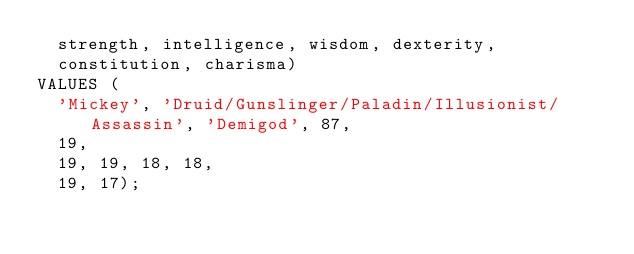<code> <loc_0><loc_0><loc_500><loc_500><_SQL_>  strength, intelligence, wisdom, dexterity,
  constitution, charisma)
VALUES (
  'Mickey', 'Druid/Gunslinger/Paladin/Illusionist/Assassin', 'Demigod', 87,
  19,
  19, 19, 18, 18,
  19, 17);
</code> 